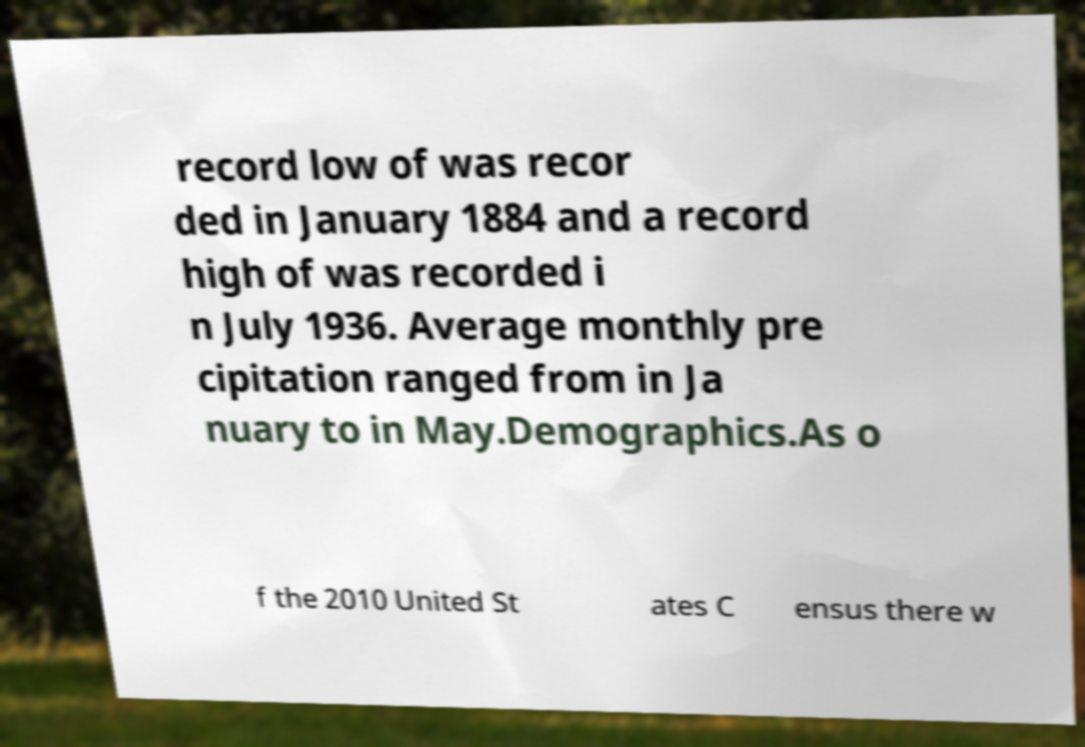Please read and relay the text visible in this image. What does it say? record low of was recor ded in January 1884 and a record high of was recorded i n July 1936. Average monthly pre cipitation ranged from in Ja nuary to in May.Demographics.As o f the 2010 United St ates C ensus there w 